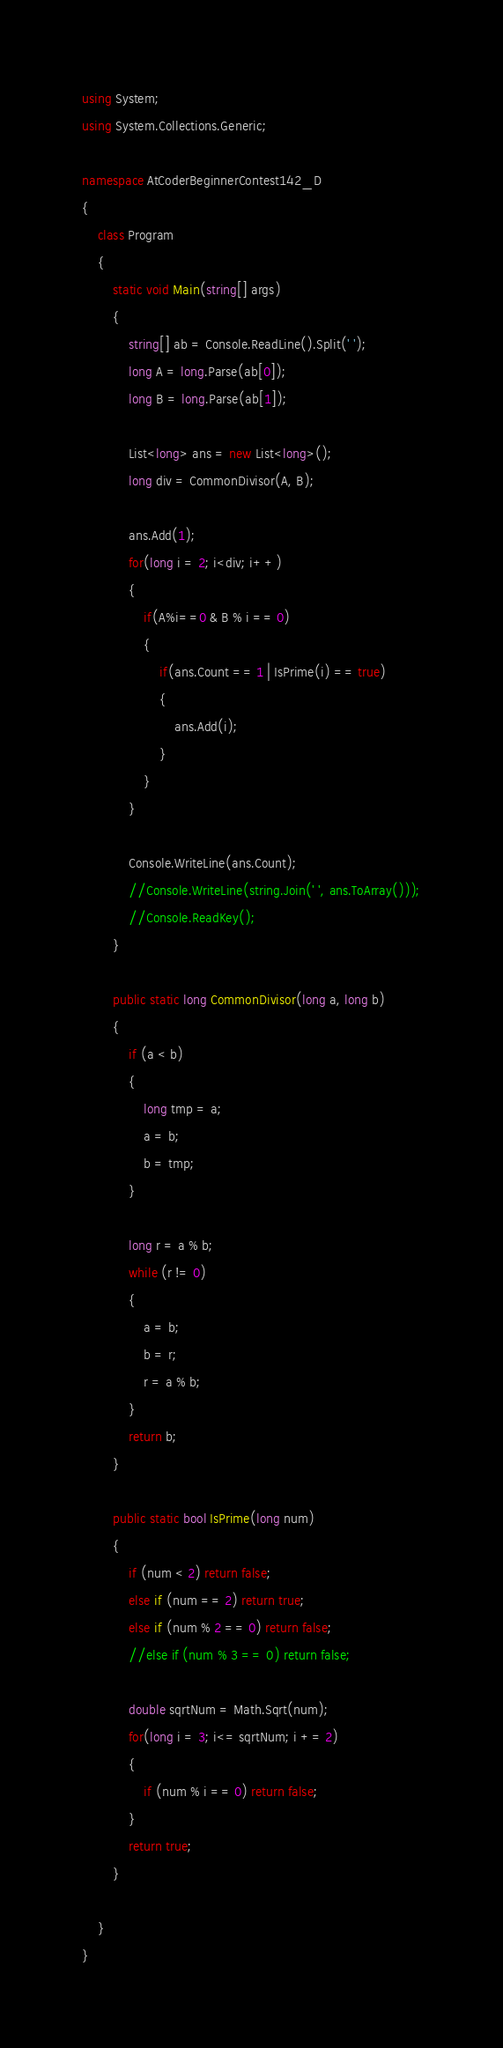Convert code to text. <code><loc_0><loc_0><loc_500><loc_500><_C#_>using System;
using System.Collections.Generic;

namespace AtCoderBeginnerContest142_D
{
    class Program
    {
        static void Main(string[] args)
        {
            string[] ab = Console.ReadLine().Split(' ');
            long A = long.Parse(ab[0]);
            long B = long.Parse(ab[1]);

            List<long> ans = new List<long>();
            long div = CommonDivisor(A, B);
            
            ans.Add(1);
            for(long i = 2; i<div; i++)
            {
                if(A%i==0 & B % i == 0)
                {
                    if(ans.Count == 1 | IsPrime(i) == true)
                    {
                        ans.Add(i);
                    }
                }
            }

            Console.WriteLine(ans.Count);
            //Console.WriteLine(string.Join(' ', ans.ToArray()));
            //Console.ReadKey();
        }

        public static long CommonDivisor(long a, long b)
        {
            if (a < b)
            {
                long tmp = a;
                a = b;
                b = tmp;
            }

            long r = a % b;
            while (r != 0)
            {
                a = b;
                b = r;
                r = a % b;
            }
            return b;
        }

        public static bool IsPrime(long num)
        {
            if (num < 2) return false;
            else if (num == 2) return true;
            else if (num % 2 == 0) return false;
            //else if (num % 3 == 0) return false;

            double sqrtNum = Math.Sqrt(num);
            for(long i = 3; i<= sqrtNum; i += 2)
            {
                if (num % i == 0) return false;
            }
            return true;
        }

    }
}
</code> 